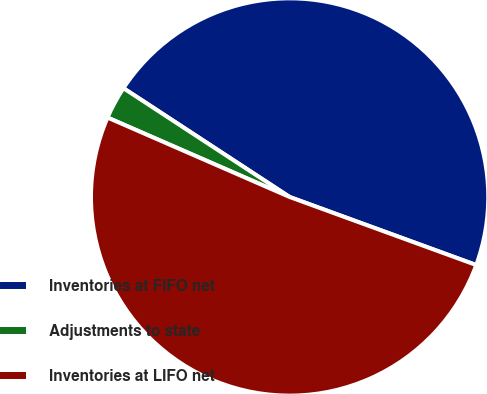Convert chart to OTSL. <chart><loc_0><loc_0><loc_500><loc_500><pie_chart><fcel>Inventories at FIFO net<fcel>Adjustments to state<fcel>Inventories at LIFO net<nl><fcel>46.34%<fcel>2.68%<fcel>50.98%<nl></chart> 